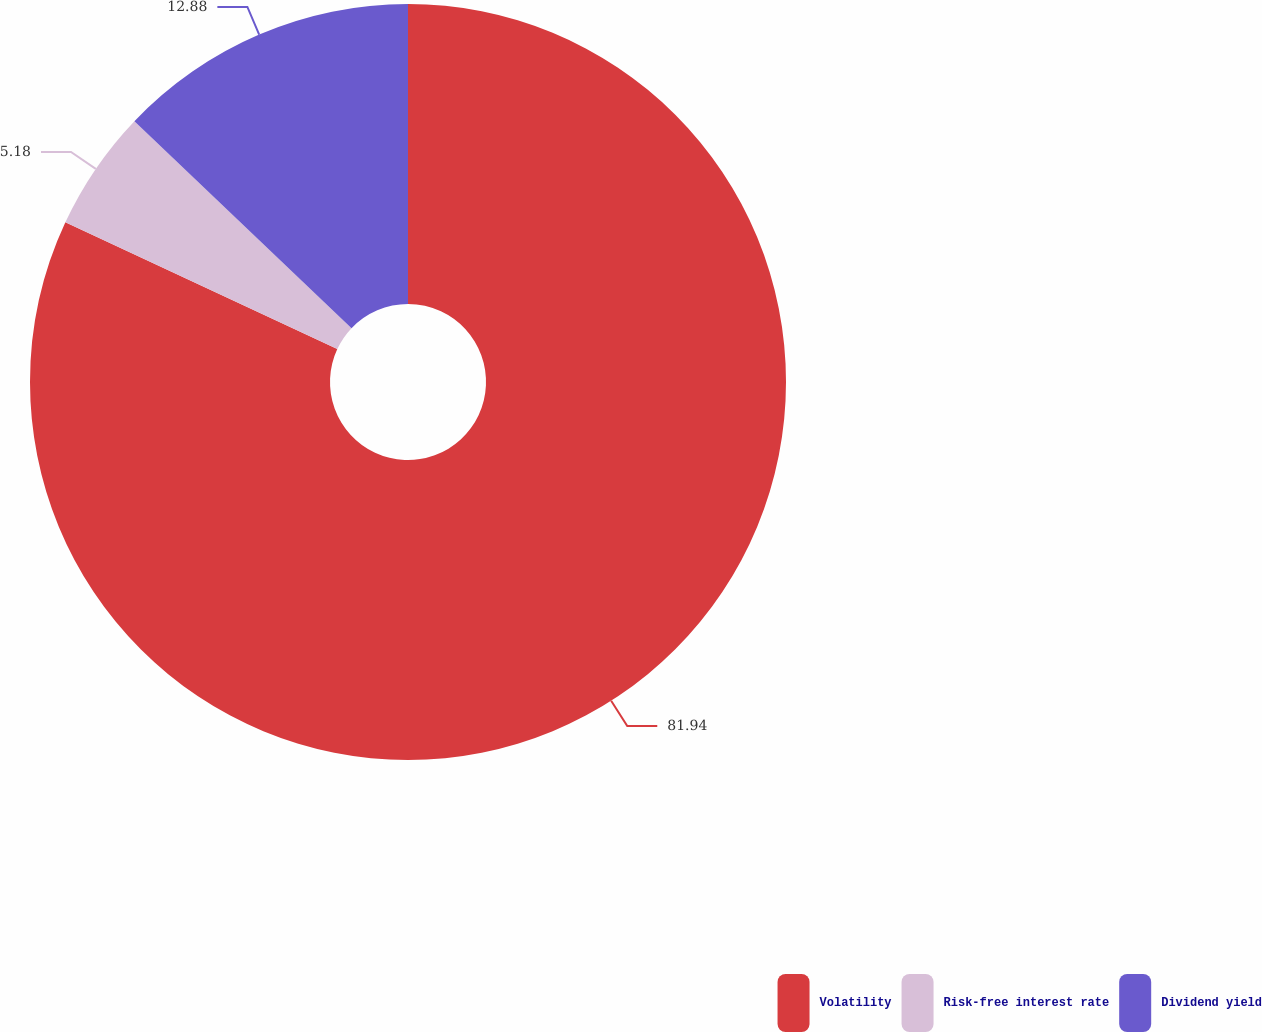<chart> <loc_0><loc_0><loc_500><loc_500><pie_chart><fcel>Volatility<fcel>Risk-free interest rate<fcel>Dividend yield<nl><fcel>81.94%<fcel>5.18%<fcel>12.88%<nl></chart> 